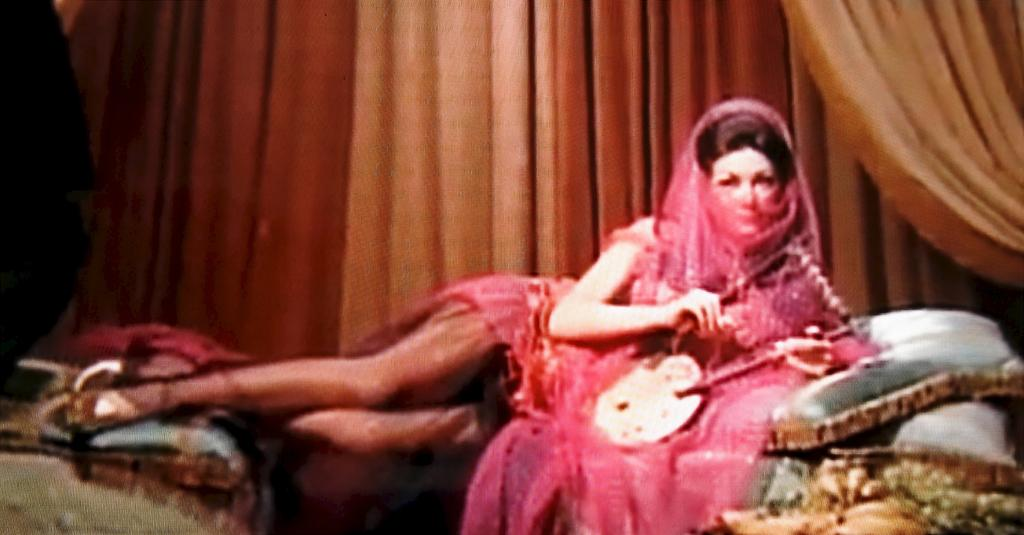How many people are in the image? There are two people in the image. What is the position of one of the people in the image? A woman is sitting. What type of soft furnishings can be seen in the image? There are pillows in the image. What can be seen in the background of the image? There are curtains visible in the background. What type of quartz is being used as a table in the image? There is no quartz present in the image, and no table made of quartz is visible. 